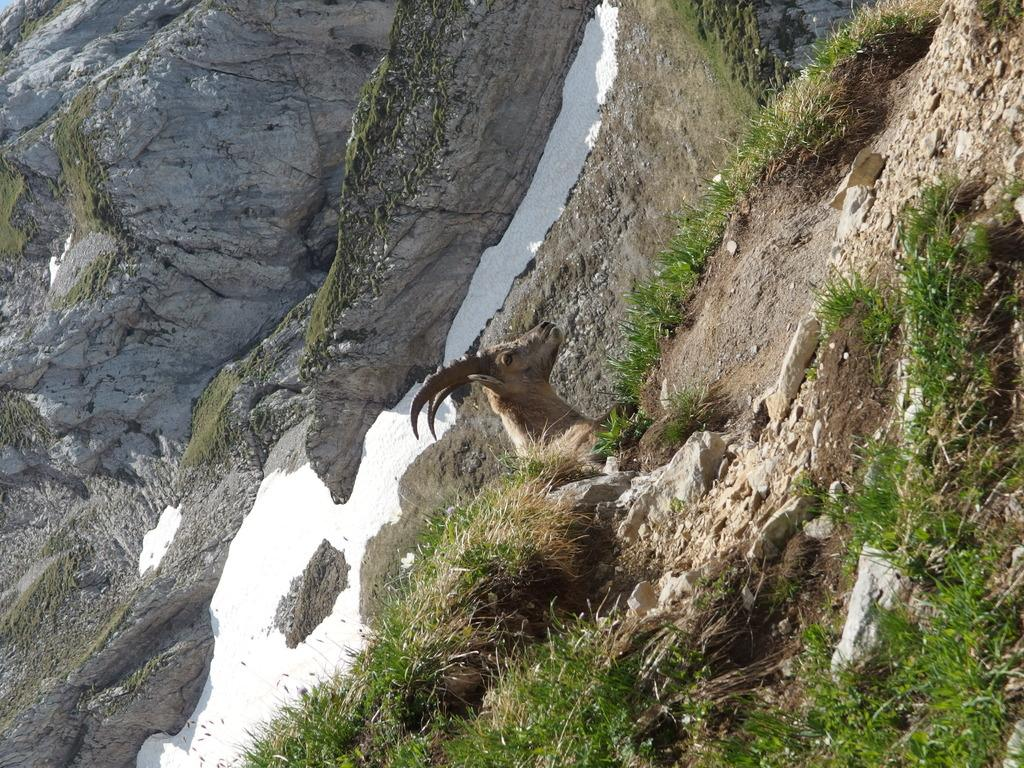What type of animal can be seen in the image? There is an animal in the image, but its specific type is not mentioned in the facts. What color is the animal in the image? The animal is brown in color. What is the weather like in the image? The presence of snow and green grass suggests that the weather is cold, but not too cold to prevent grass from growing. What natural feature is present in the image? There is a rock in the image. Can you tell me how many drawers are visible in the image? There are no drawers present in the image. What type of snail can be seen crawling on the rock in the image? There is no snail present in the image; only the animal, snow, green grass, and rock are mentioned. 